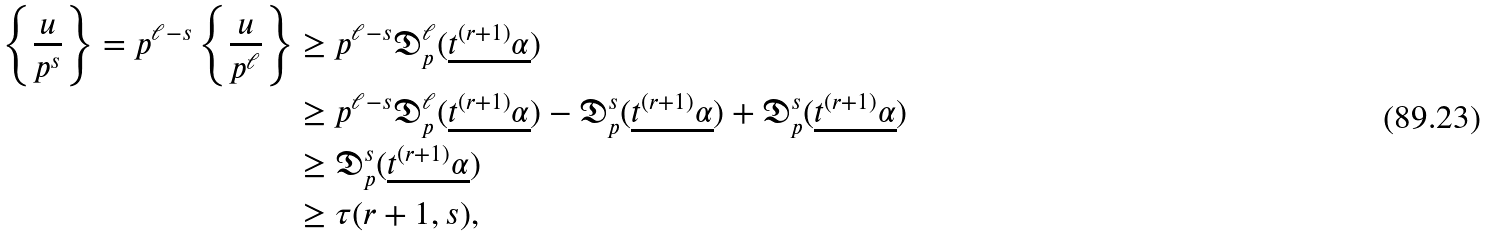<formula> <loc_0><loc_0><loc_500><loc_500>\left \{ \frac { u } { p ^ { s } } \right \} = p ^ { \ell - s } \left \{ \frac { u } { p ^ { \ell } } \right \} & \geq p ^ { \ell - s } \mathfrak { D } _ { p } ^ { \ell } ( \underline { t ^ { ( r + 1 ) } \alpha } ) \\ & \geq p ^ { \ell - s } \mathfrak { D } _ { p } ^ { \ell } ( \underline { t ^ { ( r + 1 ) } \alpha } ) - \mathfrak { D } _ { p } ^ { s } ( \underline { t ^ { ( r + 1 ) } \alpha } ) + \mathfrak { D } _ { p } ^ { s } ( \underline { t ^ { ( r + 1 ) } \alpha } ) \\ & \geq \mathfrak { D } _ { p } ^ { s } ( \underline { t ^ { ( r + 1 ) } \alpha } ) \\ & \geq \tau ( r + 1 , s ) ,</formula> 